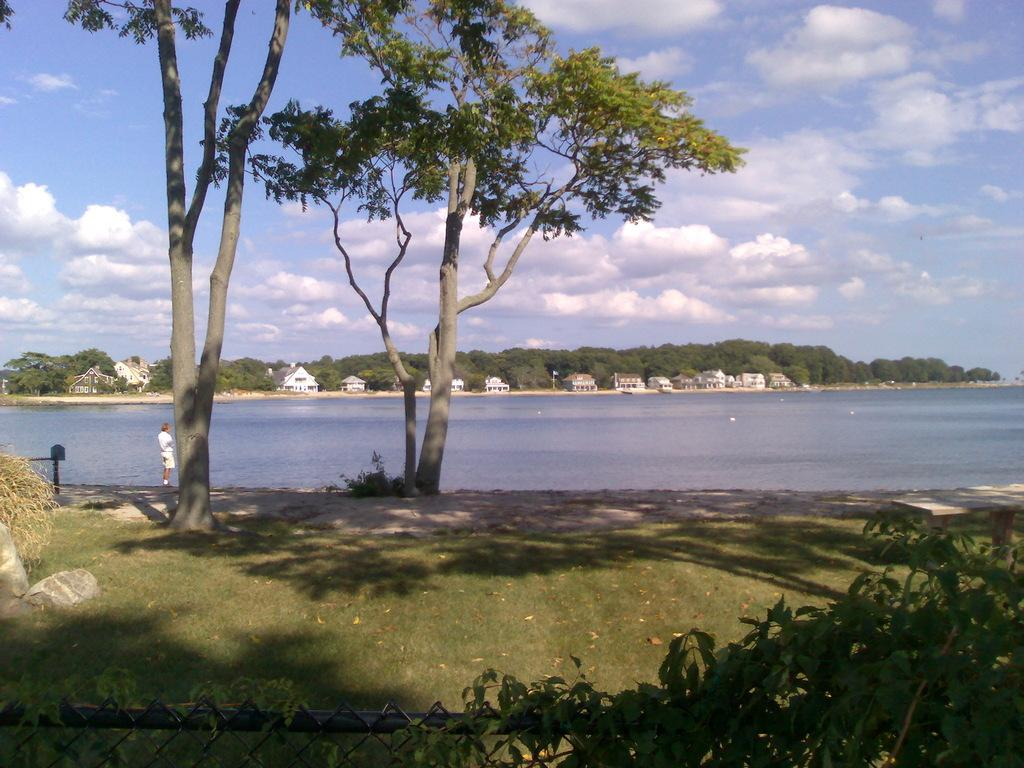What type of natural environment is visible in the image? There is grass, plants, trees, and water visible in the image. Can you describe the person in the image? There is a person in the image, but no specific details about their appearance or actions are provided. What type of structure can be seen in the image? There are houses visible in the image. What is the condition of the sky in the image? The sky is visible in the background of the image, and there are clouds present. What type of business is the person running in the image? There is no indication of a business in the image; it primarily features natural elements and a person. What type of relationship does the person have with the cats in the image? There are no cats present in the image. 